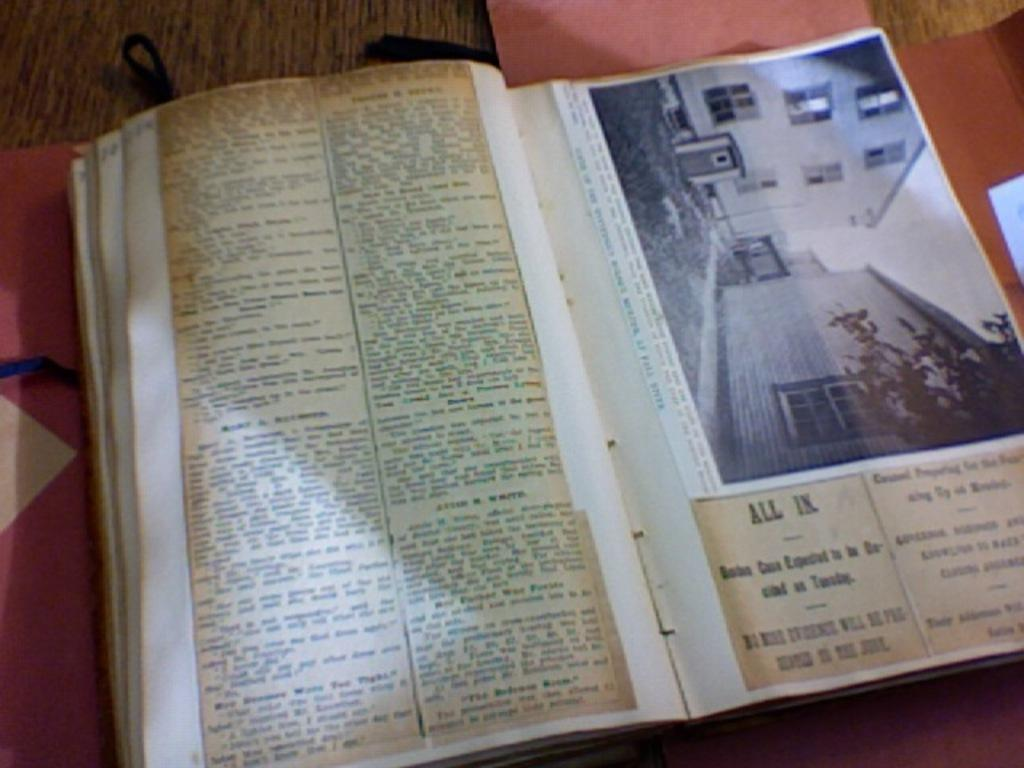<image>
Share a concise interpretation of the image provided. A book is open to a picture of a house under which lies the caption ALL IN. 